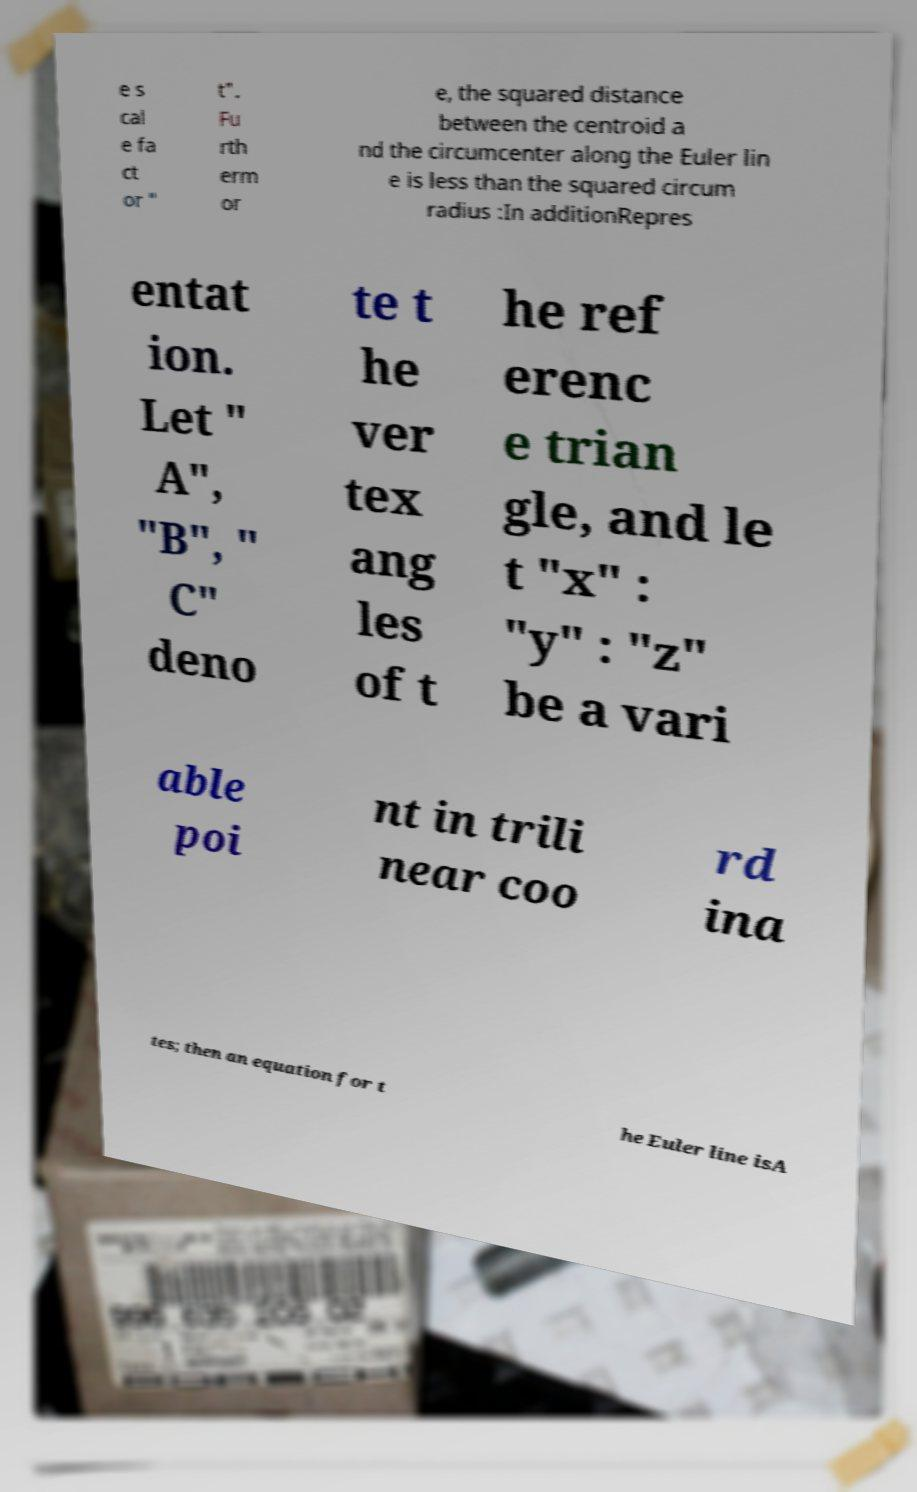Please identify and transcribe the text found in this image. e s cal e fa ct or " t". Fu rth erm or e, the squared distance between the centroid a nd the circumcenter along the Euler lin e is less than the squared circum radius :In additionRepres entat ion. Let " A", "B", " C" deno te t he ver tex ang les of t he ref erenc e trian gle, and le t "x" : "y" : "z" be a vari able poi nt in trili near coo rd ina tes; then an equation for t he Euler line isA 